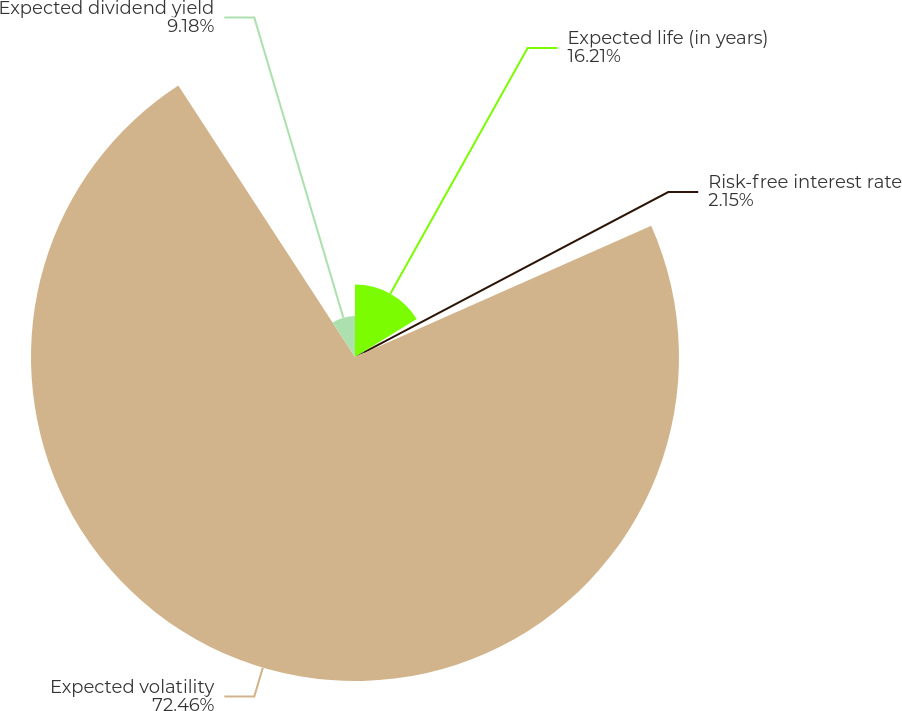Convert chart. <chart><loc_0><loc_0><loc_500><loc_500><pie_chart><fcel>Expected life (in years)<fcel>Risk-free interest rate<fcel>Expected volatility<fcel>Expected dividend yield<nl><fcel>16.21%<fcel>2.15%<fcel>72.45%<fcel>9.18%<nl></chart> 